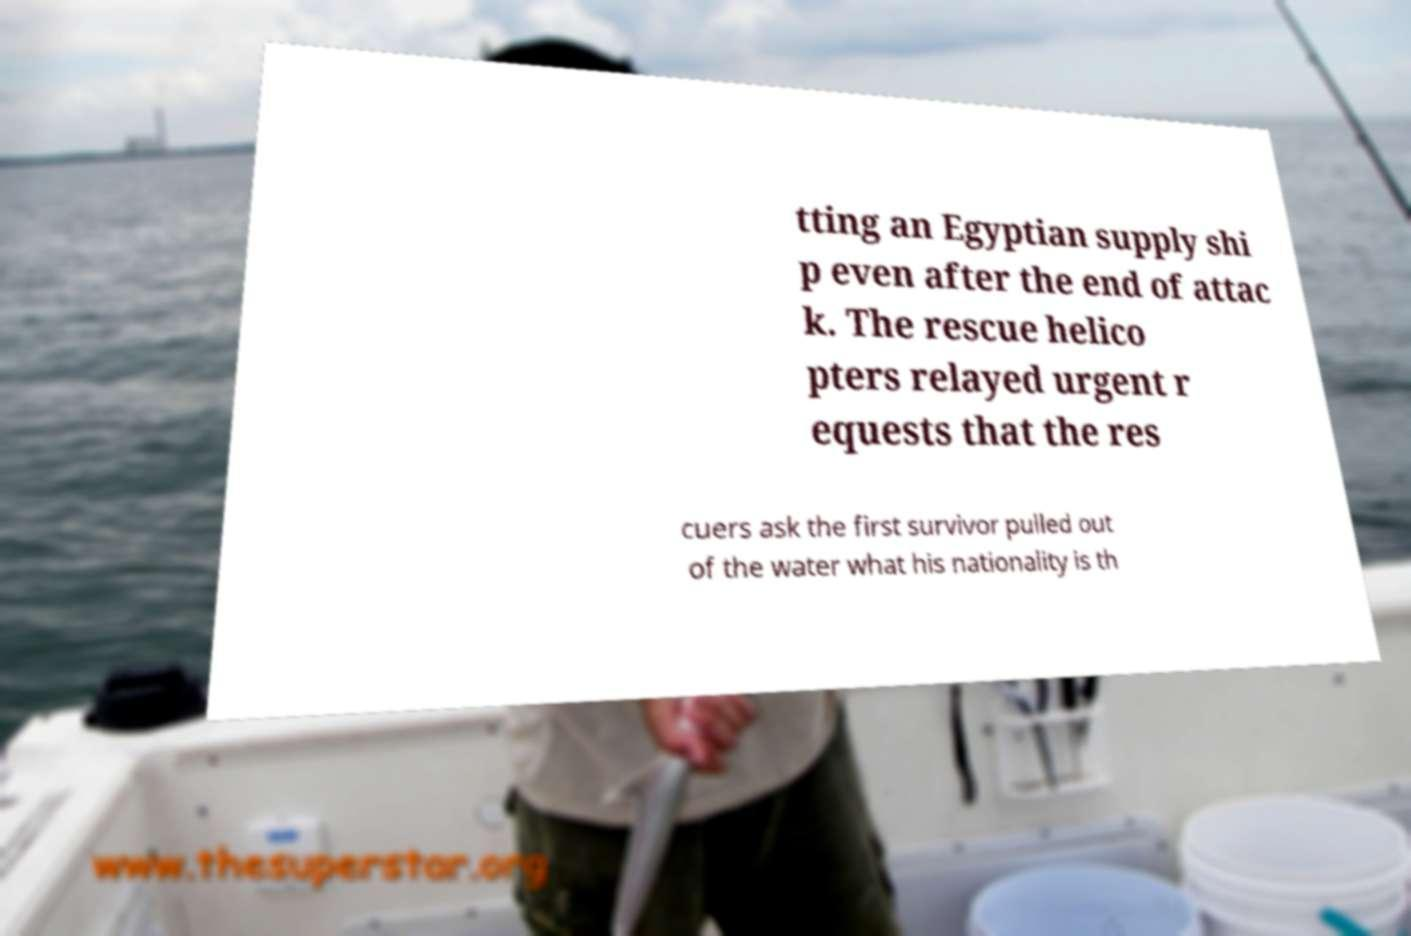There's text embedded in this image that I need extracted. Can you transcribe it verbatim? tting an Egyptian supply shi p even after the end of attac k. The rescue helico pters relayed urgent r equests that the res cuers ask the first survivor pulled out of the water what his nationality is th 